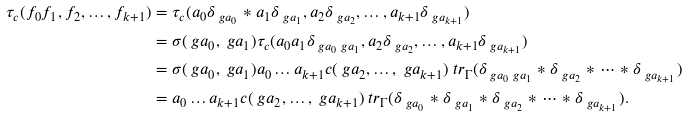Convert formula to latex. <formula><loc_0><loc_0><loc_500><loc_500>\tau _ { c } ( f _ { 0 } f _ { 1 } , f _ { 2 } , \dots , f _ { k + 1 } ) & = \tau _ { c } ( a _ { 0 } \delta _ { \ g a _ { 0 } } \ast a _ { 1 } \delta _ { \ g a _ { 1 } } , a _ { 2 } \delta _ { \ g a _ { 2 } } , \dots , a _ { k + 1 } \delta _ { \ g a _ { k + 1 } } ) \\ & = \sigma ( \ g a _ { 0 } , \ g a _ { 1 } ) \tau _ { c } ( a _ { 0 } a _ { 1 } \delta _ { \ g a _ { 0 } \ g a _ { 1 } } , a _ { 2 } \delta _ { \ g a _ { 2 } } , \dots , a _ { k + 1 } \delta _ { \ g a _ { k + 1 } } ) \\ & = \sigma ( \ g a _ { 0 } , \ g a _ { 1 } ) a _ { 0 } \dots a _ { k + 1 } c ( \ g a _ { 2 } , \dots , \ g a _ { k + 1 } ) \ t r _ { \Gamma } ( \delta _ { \ g a _ { 0 } \ g a _ { 1 } } \ast \delta _ { \ g a _ { 2 } } \ast \dots \ast \delta _ { \ g a _ { k + 1 } } ) \\ & = a _ { 0 } \dots a _ { k + 1 } c ( \ g a _ { 2 } , \dots , \ g a _ { k + 1 } ) \ t r _ { \Gamma } ( \delta _ { \ g a _ { 0 } } \ast \delta _ { \ g a _ { 1 } } \ast \delta _ { \ g a _ { 2 } } \ast \dots \ast \delta _ { \ g a _ { k + 1 } } ) .</formula> 